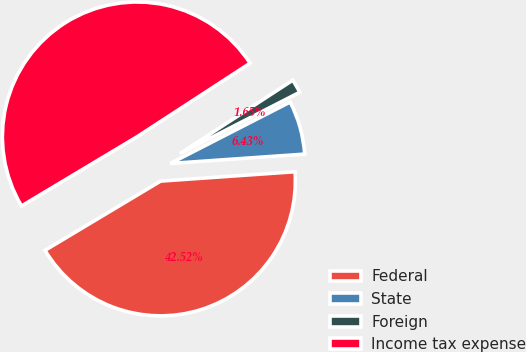Convert chart to OTSL. <chart><loc_0><loc_0><loc_500><loc_500><pie_chart><fcel>Federal<fcel>State<fcel>Foreign<fcel>Income tax expense<nl><fcel>42.52%<fcel>6.43%<fcel>1.65%<fcel>49.4%<nl></chart> 